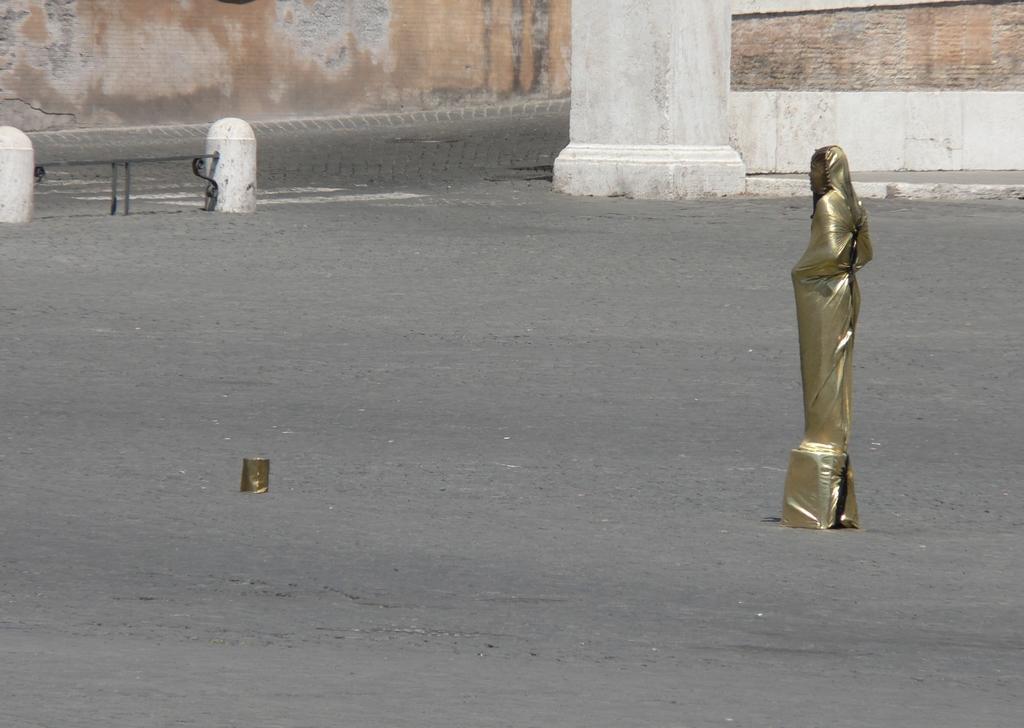How would you summarize this image in a sentence or two? In this image we can see a statue and a pillar, also we can see some objects and in the background, we can see the wall. 